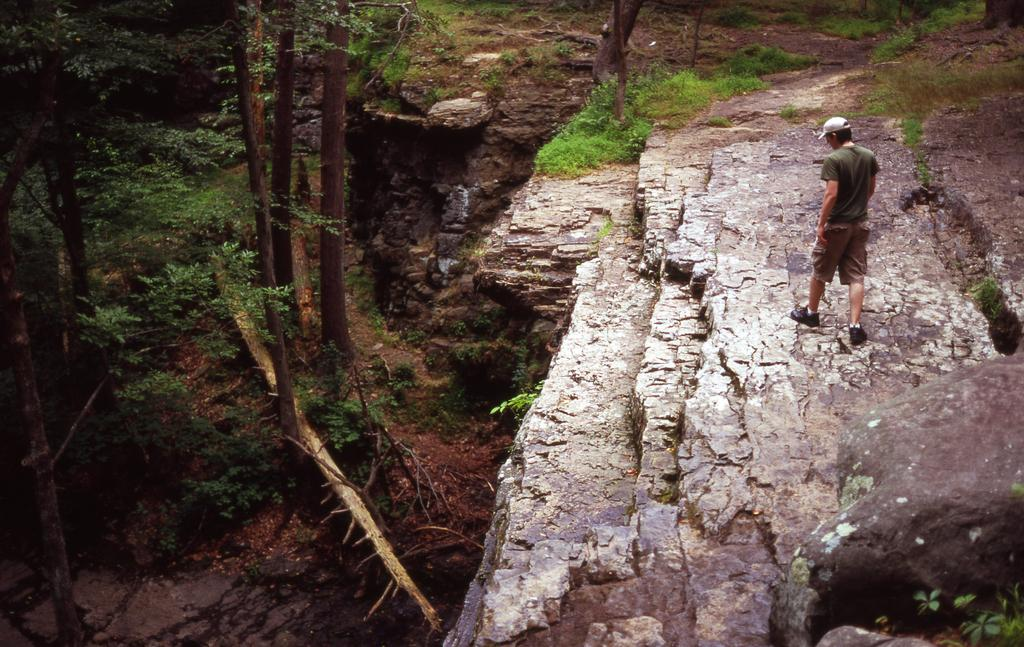What geographical feature is the main subject of the image? There is a mountain in the image. What can be seen in the valley between the mountain? There is a valley with trees in the image. What is the person in the image doing? A person is walking on the mountain. In which direction is the person facing? The person is facing towards the back. How many people are in the crowd at the bottom of the mountain in the image? There is no crowd present at the bottom of the mountain in the image. 